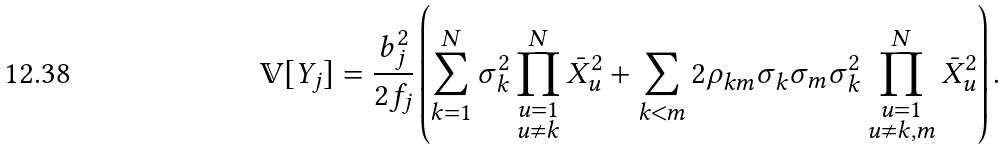Convert formula to latex. <formula><loc_0><loc_0><loc_500><loc_500>\mathbb { V } [ Y _ { j } ] = \frac { b _ { j } ^ { 2 } } { 2 f _ { j } } \left ( \sum _ { k = 1 } ^ { N } \sigma _ { k } ^ { 2 } \prod _ { \substack { u = 1 \\ u \neq k } } ^ { N } \bar { X } _ { u } ^ { 2 } + \sum _ { k < m } 2 \rho _ { k m } \sigma _ { k } \sigma _ { m } \sigma _ { k } ^ { 2 } \prod _ { \substack { u = 1 \\ u \neq k , m } } ^ { N } \bar { X } _ { u } ^ { 2 } \right ) .</formula> 